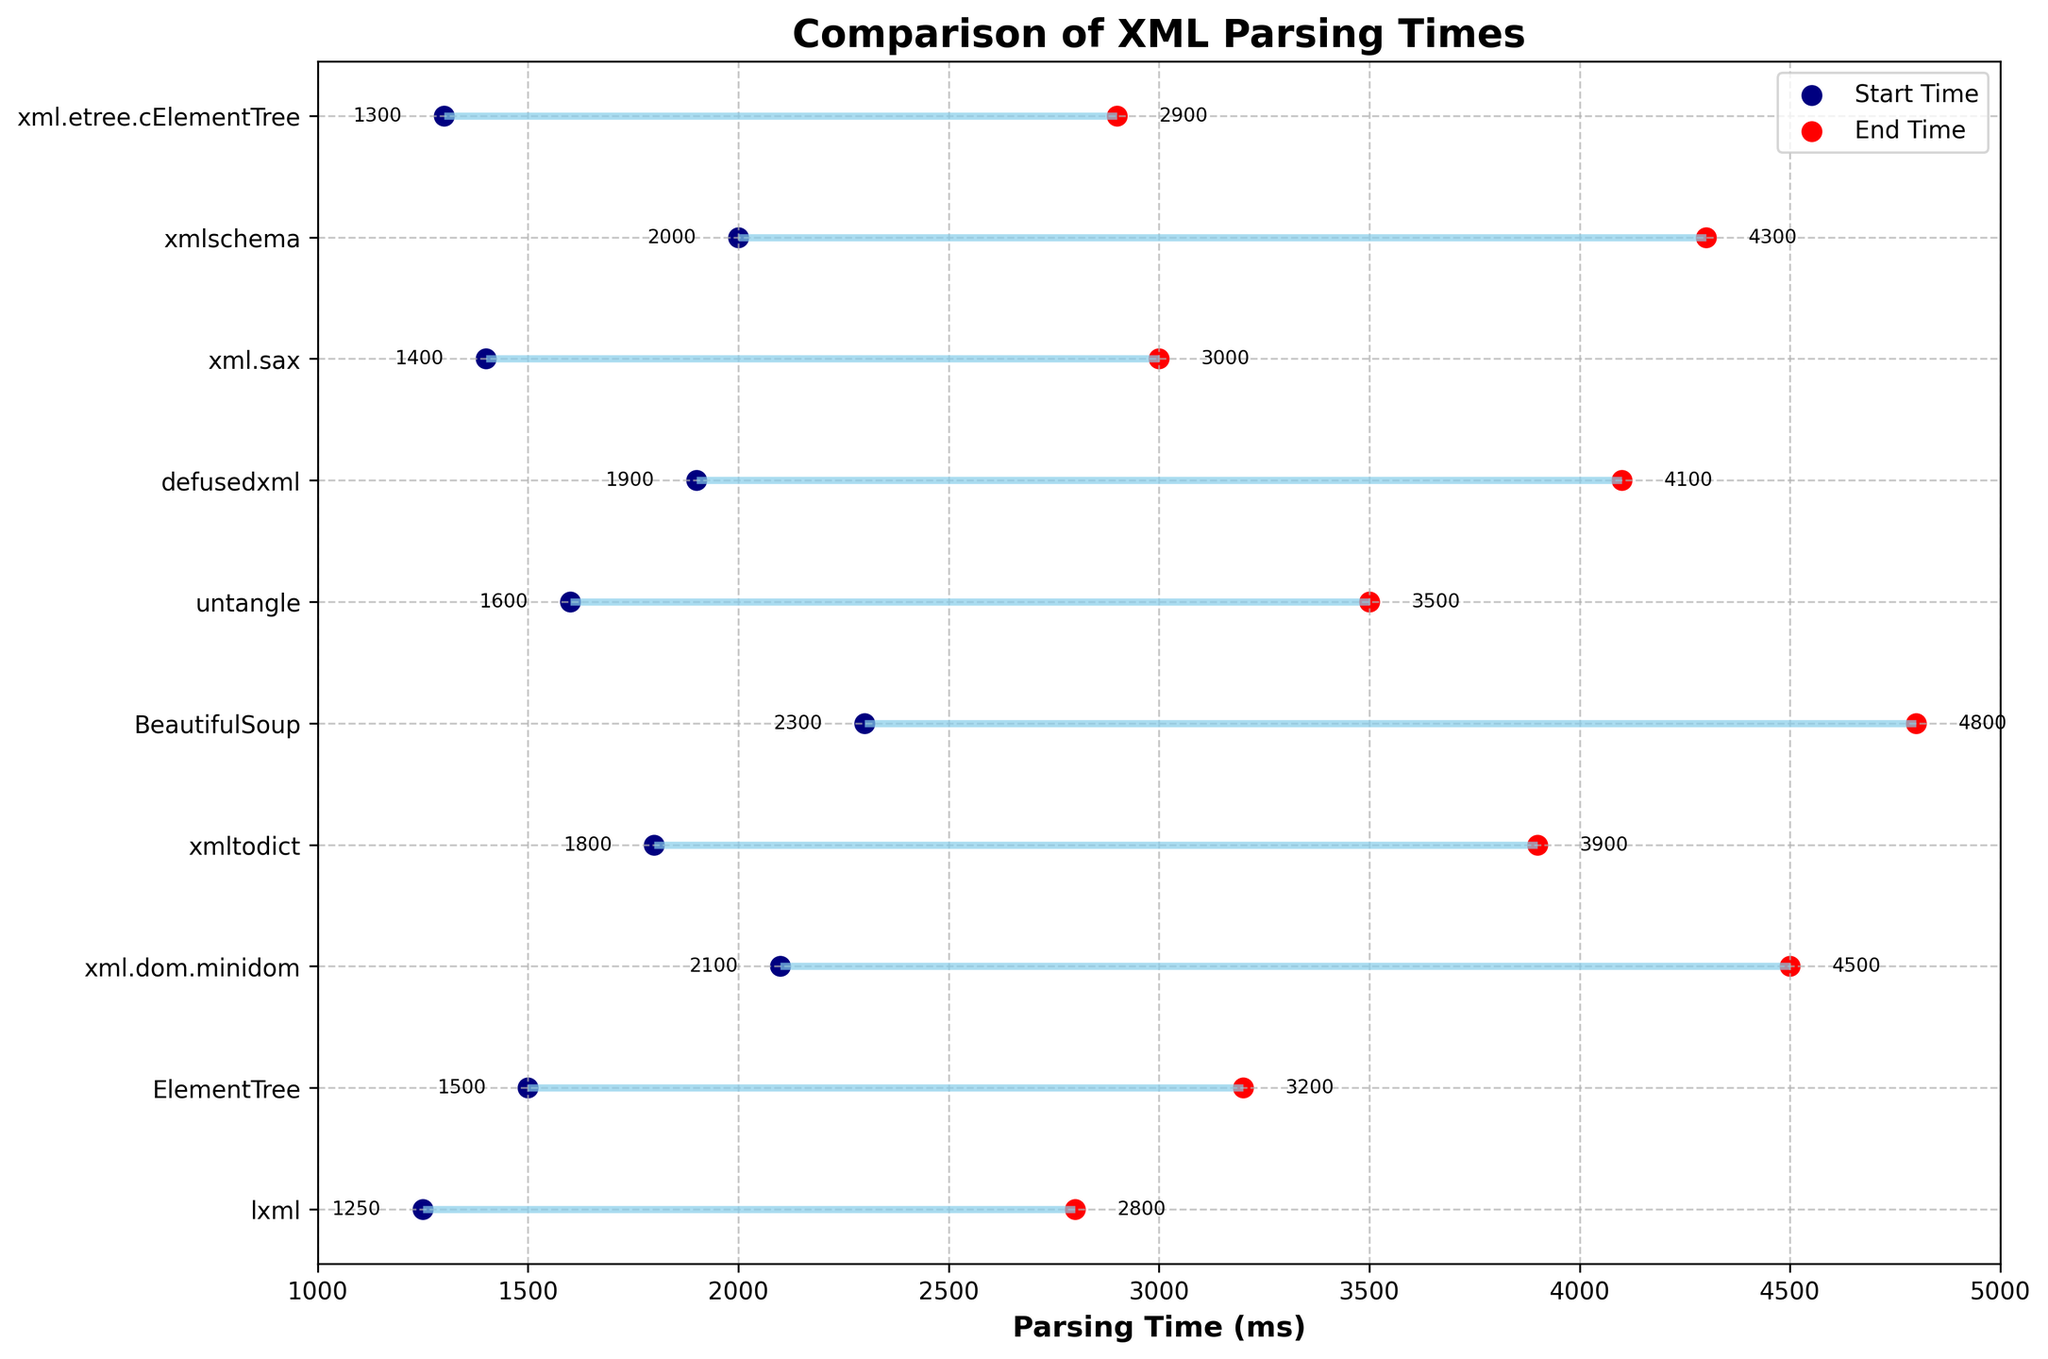What is the title of the plot? The title of the plot is positioned at the top and reads, "Comparison of XML Parsing Times".
Answer: "Comparison of XML Parsing Times" Which library has the longest start parsing time? Examine the starting times on the plot to find the highest value among the starting points. The library with the longest start parsing time is BeautifulSoup, at 2300 ms.
Answer: BeautifulSoup What is the difference in end parsing times between lxml and xml.etree.cElementTree? Find the end parsing times for both libraries: lxml (2800 ms) and xml.etree.cElementTree (2900 ms). Subtract these two values: 2900 - 2800 = 100 ms.
Answer: 100 ms How many libraries have a parsing start time less than 1600 ms? Identify libraries with start times less than 1600 ms (lxml, ElementTree, xml.sax, xml.etree.cElementTree). There are four such libraries.
Answer: 4 Which library has the shortest overall parsing duration (End_Time_ms - Start_Time_ms)? Calculate the duration for each library and find the smallest value: lxml (1550 ms), ElementTree (1700 ms), xml.dom.minidom (2400 ms), xmltodict (2100 ms), BeautifulSoup (2500 ms), untangle (1900 ms), defusedxml (2200 ms), xml.sax (1600 ms), xmlschema (2300 ms), xml.etree.cElementTree (1600 ms). The shortest duration is lxml with 1550 ms.
Answer: lxml What is the average end parsing time for all libraries? Sum all end times (2800 + 3200 + 4500 + 3900 + 4800 + 3500 + 4100 + 3000 + 4300 + 2900 = 37000 ms), then divide by the number of libraries (10): 37000 / 10 = 3700 ms.
Answer: 3700 ms Which library shows the largest increase in parsing time from start to end? Calculate parsing time increases for libraries: lxml (1550 ms), ElementTree (1700 ms), xml.dom.minidom (2400 ms), xmltodict (2100 ms), BeautifulSoup (2500 ms), untangle (1900 ms), defusedxml (2200 ms), xml.sax (1600 ms), xmlschema (2300 ms), xml.etree.cElementTree (1600 ms). The largest increase is with BeautifulSoup (2500 ms).
Answer: BeautifulSoup Which libraries have an end parsing time greater than 4000 ms? Identify libraries with end times greater than 4000 ms (xml.dom.minidom, 4500 ms; xmltodict, 3900 ms; BeautifulSoup, 4800 ms; defusedxml, 4100 ms; xmlschema, 4300 ms). There are four such libraries.
Answer: xml.dom.minidom, BeautifulSoup, defusedxml, xmlschema 